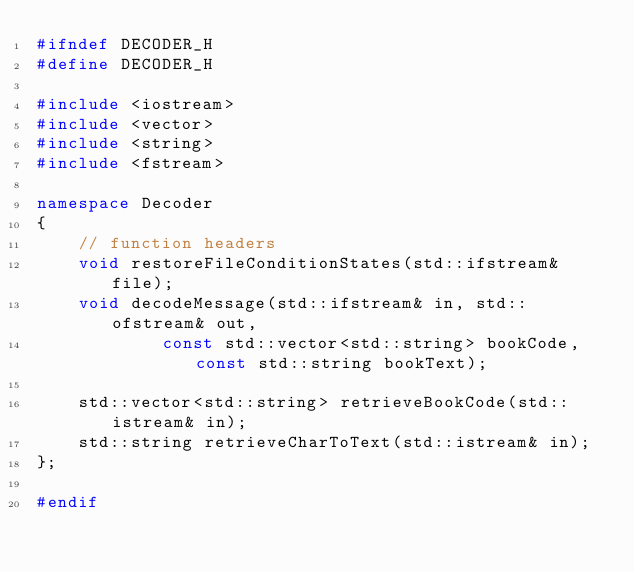Convert code to text. <code><loc_0><loc_0><loc_500><loc_500><_C++_>#ifndef DECODER_H
#define DECODER_H

#include <iostream>
#include <vector>
#include <string>
#include <fstream>

namespace Decoder
{
    // function headers
    void restoreFileConditionStates(std::ifstream& file);
    void decodeMessage(std::ifstream& in, std::ofstream& out,
            const std::vector<std::string> bookCode, const std::string bookText);

    std::vector<std::string> retrieveBookCode(std::istream& in);
    std::string retrieveCharToText(std::istream& in);
};

#endif

</code> 